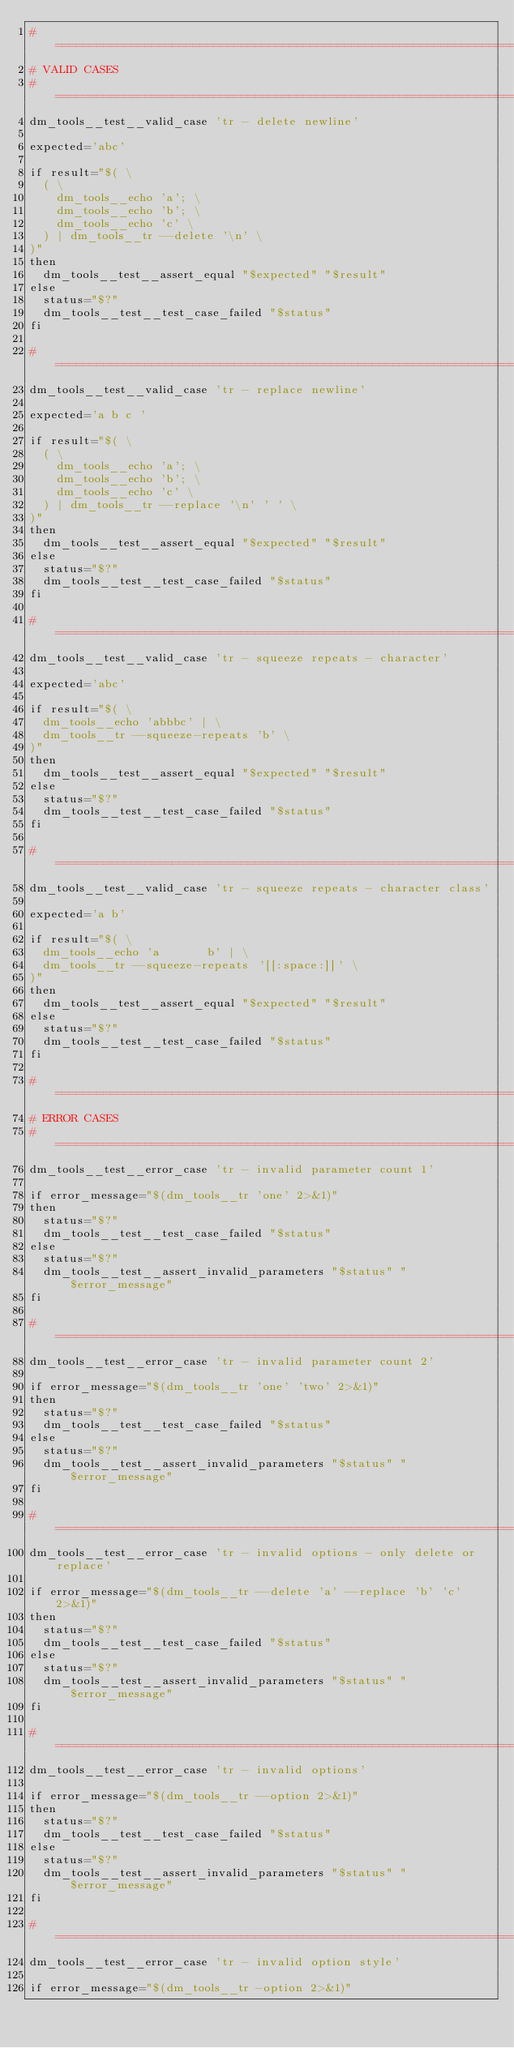<code> <loc_0><loc_0><loc_500><loc_500><_Bash_>#==============================================================================
# VALID CASES
#==============================================================================
dm_tools__test__valid_case 'tr - delete newline'

expected='abc'

if result="$( \
  ( \
    dm_tools__echo 'a'; \
    dm_tools__echo 'b'; \
    dm_tools__echo 'c' \
  ) | dm_tools__tr --delete '\n' \
)"
then
  dm_tools__test__assert_equal "$expected" "$result"
else
  status="$?"
  dm_tools__test__test_case_failed "$status"
fi

#==============================================================================
dm_tools__test__valid_case 'tr - replace newline'

expected='a b c '

if result="$( \
  ( \
    dm_tools__echo 'a'; \
    dm_tools__echo 'b'; \
    dm_tools__echo 'c' \
  ) | dm_tools__tr --replace '\n' ' ' \
)"
then
  dm_tools__test__assert_equal "$expected" "$result"
else
  status="$?"
  dm_tools__test__test_case_failed "$status"
fi

#==============================================================================
dm_tools__test__valid_case 'tr - squeeze repeats - character'

expected='abc'

if result="$( \
  dm_tools__echo 'abbbc' | \
  dm_tools__tr --squeeze-repeats 'b' \
)"
then
  dm_tools__test__assert_equal "$expected" "$result"
else
  status="$?"
  dm_tools__test__test_case_failed "$status"
fi

#==============================================================================
dm_tools__test__valid_case 'tr - squeeze repeats - character class'

expected='a b'

if result="$( \
  dm_tools__echo 'a       b' | \
  dm_tools__tr --squeeze-repeats '[[:space:]]' \
)"
then
  dm_tools__test__assert_equal "$expected" "$result"
else
  status="$?"
  dm_tools__test__test_case_failed "$status"
fi

#==============================================================================
# ERROR CASES
#==============================================================================
dm_tools__test__error_case 'tr - invalid parameter count 1'

if error_message="$(dm_tools__tr 'one' 2>&1)"
then
  status="$?"
  dm_tools__test__test_case_failed "$status"
else
  status="$?"
  dm_tools__test__assert_invalid_parameters "$status" "$error_message"
fi

#==============================================================================
dm_tools__test__error_case 'tr - invalid parameter count 2'

if error_message="$(dm_tools__tr 'one' 'two' 2>&1)"
then
  status="$?"
  dm_tools__test__test_case_failed "$status"
else
  status="$?"
  dm_tools__test__assert_invalid_parameters "$status" "$error_message"
fi

#==============================================================================
dm_tools__test__error_case 'tr - invalid options - only delete or replace'

if error_message="$(dm_tools__tr --delete 'a' --replace 'b' 'c' 2>&1)"
then
  status="$?"
  dm_tools__test__test_case_failed "$status"
else
  status="$?"
  dm_tools__test__assert_invalid_parameters "$status" "$error_message"
fi

#==============================================================================
dm_tools__test__error_case 'tr - invalid options'

if error_message="$(dm_tools__tr --option 2>&1)"
then
  status="$?"
  dm_tools__test__test_case_failed "$status"
else
  status="$?"
  dm_tools__test__assert_invalid_parameters "$status" "$error_message"
fi

#==============================================================================
dm_tools__test__error_case 'tr - invalid option style'

if error_message="$(dm_tools__tr -option 2>&1)"</code> 